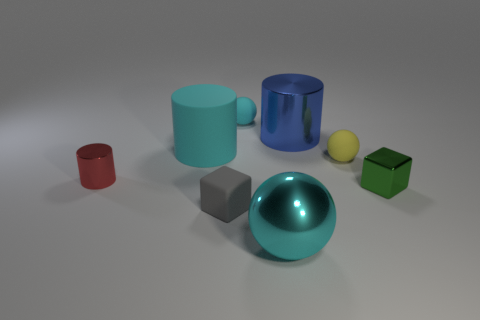What shape is the matte thing that is the same size as the blue metallic cylinder?
Offer a terse response. Cylinder. Is the color of the rubber cube the same as the large cylinder that is on the right side of the big cyan ball?
Offer a terse response. No. What number of objects are big metal things that are behind the large rubber cylinder or small blocks that are to the right of the tiny gray block?
Offer a very short reply. 2. There is a gray block that is the same size as the cyan matte sphere; what material is it?
Your answer should be very brief. Rubber. How many other things are there of the same material as the large blue cylinder?
Your response must be concise. 3. There is a cyan thing that is in front of the big cyan rubber cylinder; does it have the same shape as the big cyan object behind the small cylinder?
Keep it short and to the point. No. What is the color of the metal cylinder on the left side of the gray rubber cube in front of the big cyan thing that is behind the gray object?
Offer a terse response. Red. What number of other objects are the same color as the large rubber object?
Provide a succinct answer. 2. Are there fewer tiny cyan balls than large yellow cylinders?
Your response must be concise. No. What is the color of the object that is left of the small rubber block and behind the small red object?
Your answer should be very brief. Cyan. 